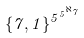Convert formula to latex. <formula><loc_0><loc_0><loc_500><loc_500>\{ 7 , 1 \} ^ { 5 ^ { 5 ^ { \aleph _ { 7 } } } }</formula> 